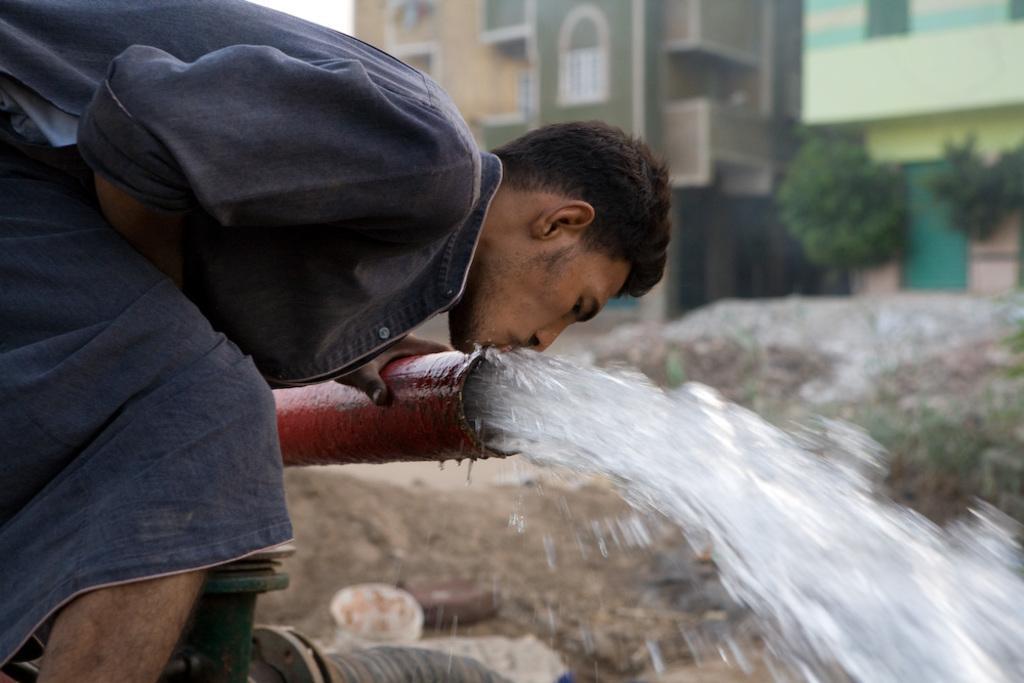Please provide a concise description of this image. In the image I can see a person who is bending and drinking the water from the pipe and to the side there are some houses, trees. 